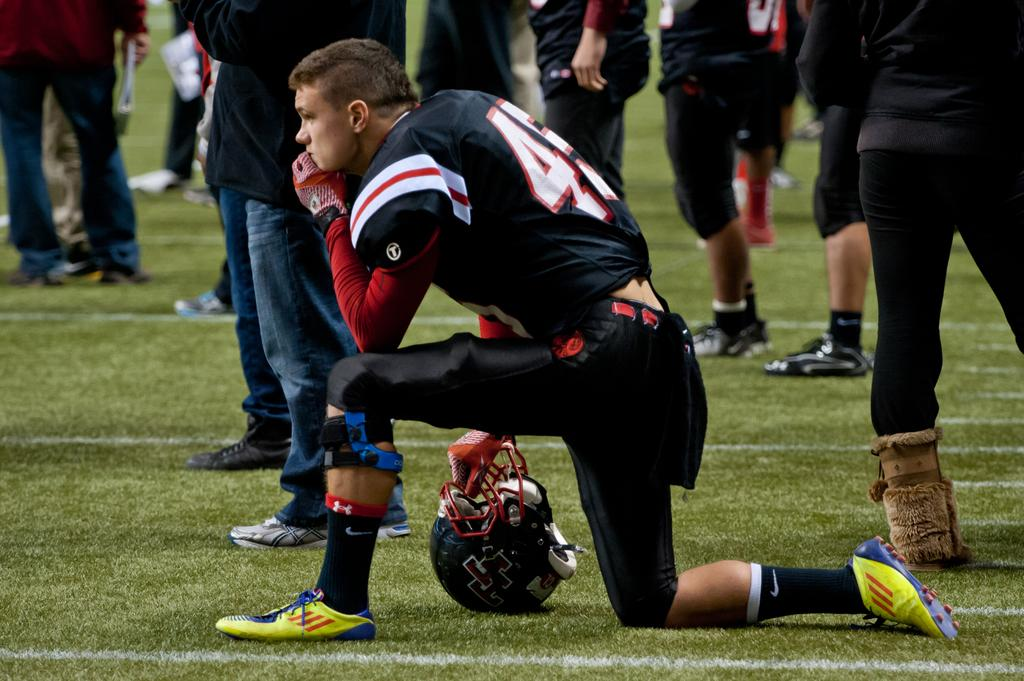Who is present in the image? There is a man in the image. What is the man wearing on his hand? The man is wearing a glove. What object is the man holding? The man is holding a helmet. Where is the helmet located in the image? The helmet is visible on the grass. Can you describe the people in the background of the image? There are people standing in the background of the image. What type of boundary can be seen in the image? There is no boundary visible in the image. Is there an oven present in the image? No, there is no oven present in the image. 